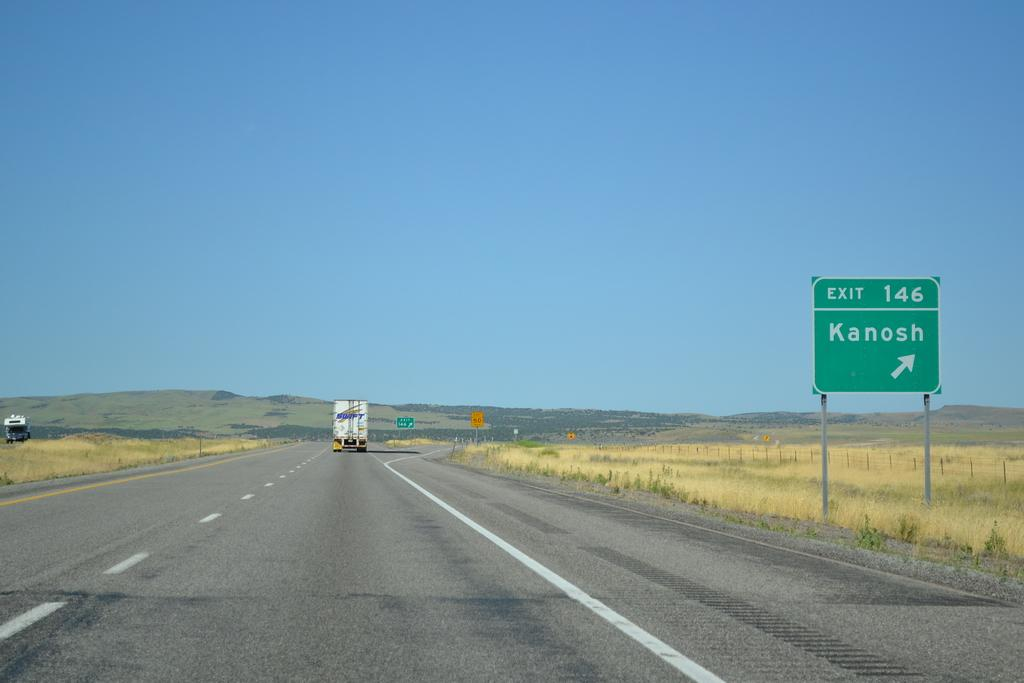<image>
Offer a succinct explanation of the picture presented. An exit sign points to the right to Kanosh. 